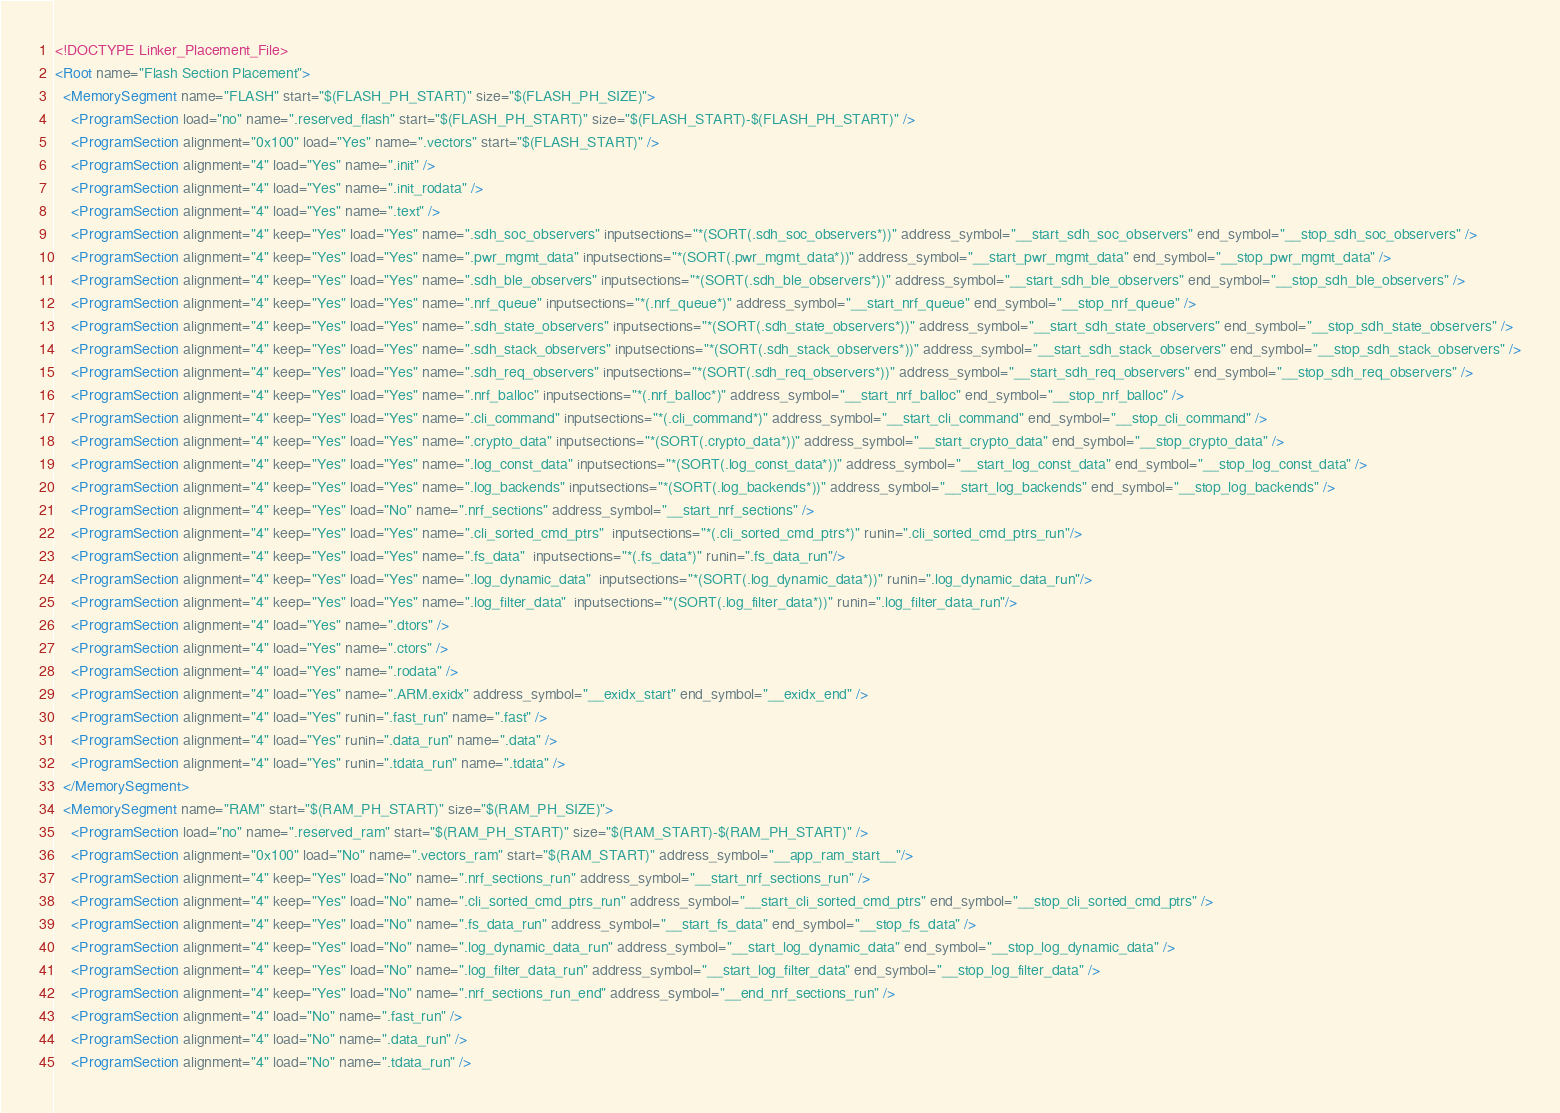Convert code to text. <code><loc_0><loc_0><loc_500><loc_500><_XML_><!DOCTYPE Linker_Placement_File>
<Root name="Flash Section Placement">
  <MemorySegment name="FLASH" start="$(FLASH_PH_START)" size="$(FLASH_PH_SIZE)">
    <ProgramSection load="no" name=".reserved_flash" start="$(FLASH_PH_START)" size="$(FLASH_START)-$(FLASH_PH_START)" />
    <ProgramSection alignment="0x100" load="Yes" name=".vectors" start="$(FLASH_START)" />
    <ProgramSection alignment="4" load="Yes" name=".init" />
    <ProgramSection alignment="4" load="Yes" name=".init_rodata" />
    <ProgramSection alignment="4" load="Yes" name=".text" />
    <ProgramSection alignment="4" keep="Yes" load="Yes" name=".sdh_soc_observers" inputsections="*(SORT(.sdh_soc_observers*))" address_symbol="__start_sdh_soc_observers" end_symbol="__stop_sdh_soc_observers" />
    <ProgramSection alignment="4" keep="Yes" load="Yes" name=".pwr_mgmt_data" inputsections="*(SORT(.pwr_mgmt_data*))" address_symbol="__start_pwr_mgmt_data" end_symbol="__stop_pwr_mgmt_data" />
    <ProgramSection alignment="4" keep="Yes" load="Yes" name=".sdh_ble_observers" inputsections="*(SORT(.sdh_ble_observers*))" address_symbol="__start_sdh_ble_observers" end_symbol="__stop_sdh_ble_observers" />
    <ProgramSection alignment="4" keep="Yes" load="Yes" name=".nrf_queue" inputsections="*(.nrf_queue*)" address_symbol="__start_nrf_queue" end_symbol="__stop_nrf_queue" />
    <ProgramSection alignment="4" keep="Yes" load="Yes" name=".sdh_state_observers" inputsections="*(SORT(.sdh_state_observers*))" address_symbol="__start_sdh_state_observers" end_symbol="__stop_sdh_state_observers" />
    <ProgramSection alignment="4" keep="Yes" load="Yes" name=".sdh_stack_observers" inputsections="*(SORT(.sdh_stack_observers*))" address_symbol="__start_sdh_stack_observers" end_symbol="__stop_sdh_stack_observers" />
    <ProgramSection alignment="4" keep="Yes" load="Yes" name=".sdh_req_observers" inputsections="*(SORT(.sdh_req_observers*))" address_symbol="__start_sdh_req_observers" end_symbol="__stop_sdh_req_observers" />
    <ProgramSection alignment="4" keep="Yes" load="Yes" name=".nrf_balloc" inputsections="*(.nrf_balloc*)" address_symbol="__start_nrf_balloc" end_symbol="__stop_nrf_balloc" />
    <ProgramSection alignment="4" keep="Yes" load="Yes" name=".cli_command" inputsections="*(.cli_command*)" address_symbol="__start_cli_command" end_symbol="__stop_cli_command" />
    <ProgramSection alignment="4" keep="Yes" load="Yes" name=".crypto_data" inputsections="*(SORT(.crypto_data*))" address_symbol="__start_crypto_data" end_symbol="__stop_crypto_data" />
    <ProgramSection alignment="4" keep="Yes" load="Yes" name=".log_const_data" inputsections="*(SORT(.log_const_data*))" address_symbol="__start_log_const_data" end_symbol="__stop_log_const_data" />
    <ProgramSection alignment="4" keep="Yes" load="Yes" name=".log_backends" inputsections="*(SORT(.log_backends*))" address_symbol="__start_log_backends" end_symbol="__stop_log_backends" />
    <ProgramSection alignment="4" keep="Yes" load="No" name=".nrf_sections" address_symbol="__start_nrf_sections" />
    <ProgramSection alignment="4" keep="Yes" load="Yes" name=".cli_sorted_cmd_ptrs"  inputsections="*(.cli_sorted_cmd_ptrs*)" runin=".cli_sorted_cmd_ptrs_run"/>
    <ProgramSection alignment="4" keep="Yes" load="Yes" name=".fs_data"  inputsections="*(.fs_data*)" runin=".fs_data_run"/>
    <ProgramSection alignment="4" keep="Yes" load="Yes" name=".log_dynamic_data"  inputsections="*(SORT(.log_dynamic_data*))" runin=".log_dynamic_data_run"/>
    <ProgramSection alignment="4" keep="Yes" load="Yes" name=".log_filter_data"  inputsections="*(SORT(.log_filter_data*))" runin=".log_filter_data_run"/>
    <ProgramSection alignment="4" load="Yes" name=".dtors" />
    <ProgramSection alignment="4" load="Yes" name=".ctors" />
    <ProgramSection alignment="4" load="Yes" name=".rodata" />
    <ProgramSection alignment="4" load="Yes" name=".ARM.exidx" address_symbol="__exidx_start" end_symbol="__exidx_end" />
    <ProgramSection alignment="4" load="Yes" runin=".fast_run" name=".fast" />
    <ProgramSection alignment="4" load="Yes" runin=".data_run" name=".data" />
    <ProgramSection alignment="4" load="Yes" runin=".tdata_run" name=".tdata" />
  </MemorySegment>
  <MemorySegment name="RAM" start="$(RAM_PH_START)" size="$(RAM_PH_SIZE)">
    <ProgramSection load="no" name=".reserved_ram" start="$(RAM_PH_START)" size="$(RAM_START)-$(RAM_PH_START)" />
    <ProgramSection alignment="0x100" load="No" name=".vectors_ram" start="$(RAM_START)" address_symbol="__app_ram_start__"/>
    <ProgramSection alignment="4" keep="Yes" load="No" name=".nrf_sections_run" address_symbol="__start_nrf_sections_run" />
    <ProgramSection alignment="4" keep="Yes" load="No" name=".cli_sorted_cmd_ptrs_run" address_symbol="__start_cli_sorted_cmd_ptrs" end_symbol="__stop_cli_sorted_cmd_ptrs" />
    <ProgramSection alignment="4" keep="Yes" load="No" name=".fs_data_run" address_symbol="__start_fs_data" end_symbol="__stop_fs_data" />
    <ProgramSection alignment="4" keep="Yes" load="No" name=".log_dynamic_data_run" address_symbol="__start_log_dynamic_data" end_symbol="__stop_log_dynamic_data" />
    <ProgramSection alignment="4" keep="Yes" load="No" name=".log_filter_data_run" address_symbol="__start_log_filter_data" end_symbol="__stop_log_filter_data" />
    <ProgramSection alignment="4" keep="Yes" load="No" name=".nrf_sections_run_end" address_symbol="__end_nrf_sections_run" />
    <ProgramSection alignment="4" load="No" name=".fast_run" />
    <ProgramSection alignment="4" load="No" name=".data_run" />
    <ProgramSection alignment="4" load="No" name=".tdata_run" /></code> 